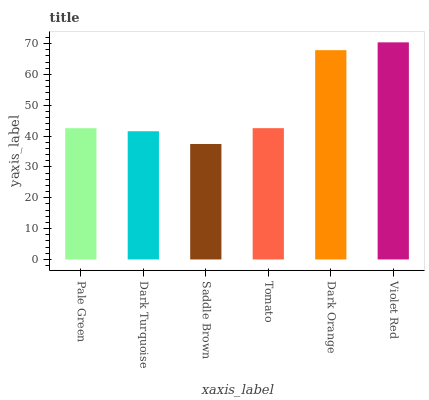Is Violet Red the maximum?
Answer yes or no. Yes. Is Dark Turquoise the minimum?
Answer yes or no. No. Is Dark Turquoise the maximum?
Answer yes or no. No. Is Pale Green greater than Dark Turquoise?
Answer yes or no. Yes. Is Dark Turquoise less than Pale Green?
Answer yes or no. Yes. Is Dark Turquoise greater than Pale Green?
Answer yes or no. No. Is Pale Green less than Dark Turquoise?
Answer yes or no. No. Is Tomato the high median?
Answer yes or no. Yes. Is Pale Green the low median?
Answer yes or no. Yes. Is Dark Turquoise the high median?
Answer yes or no. No. Is Violet Red the low median?
Answer yes or no. No. 